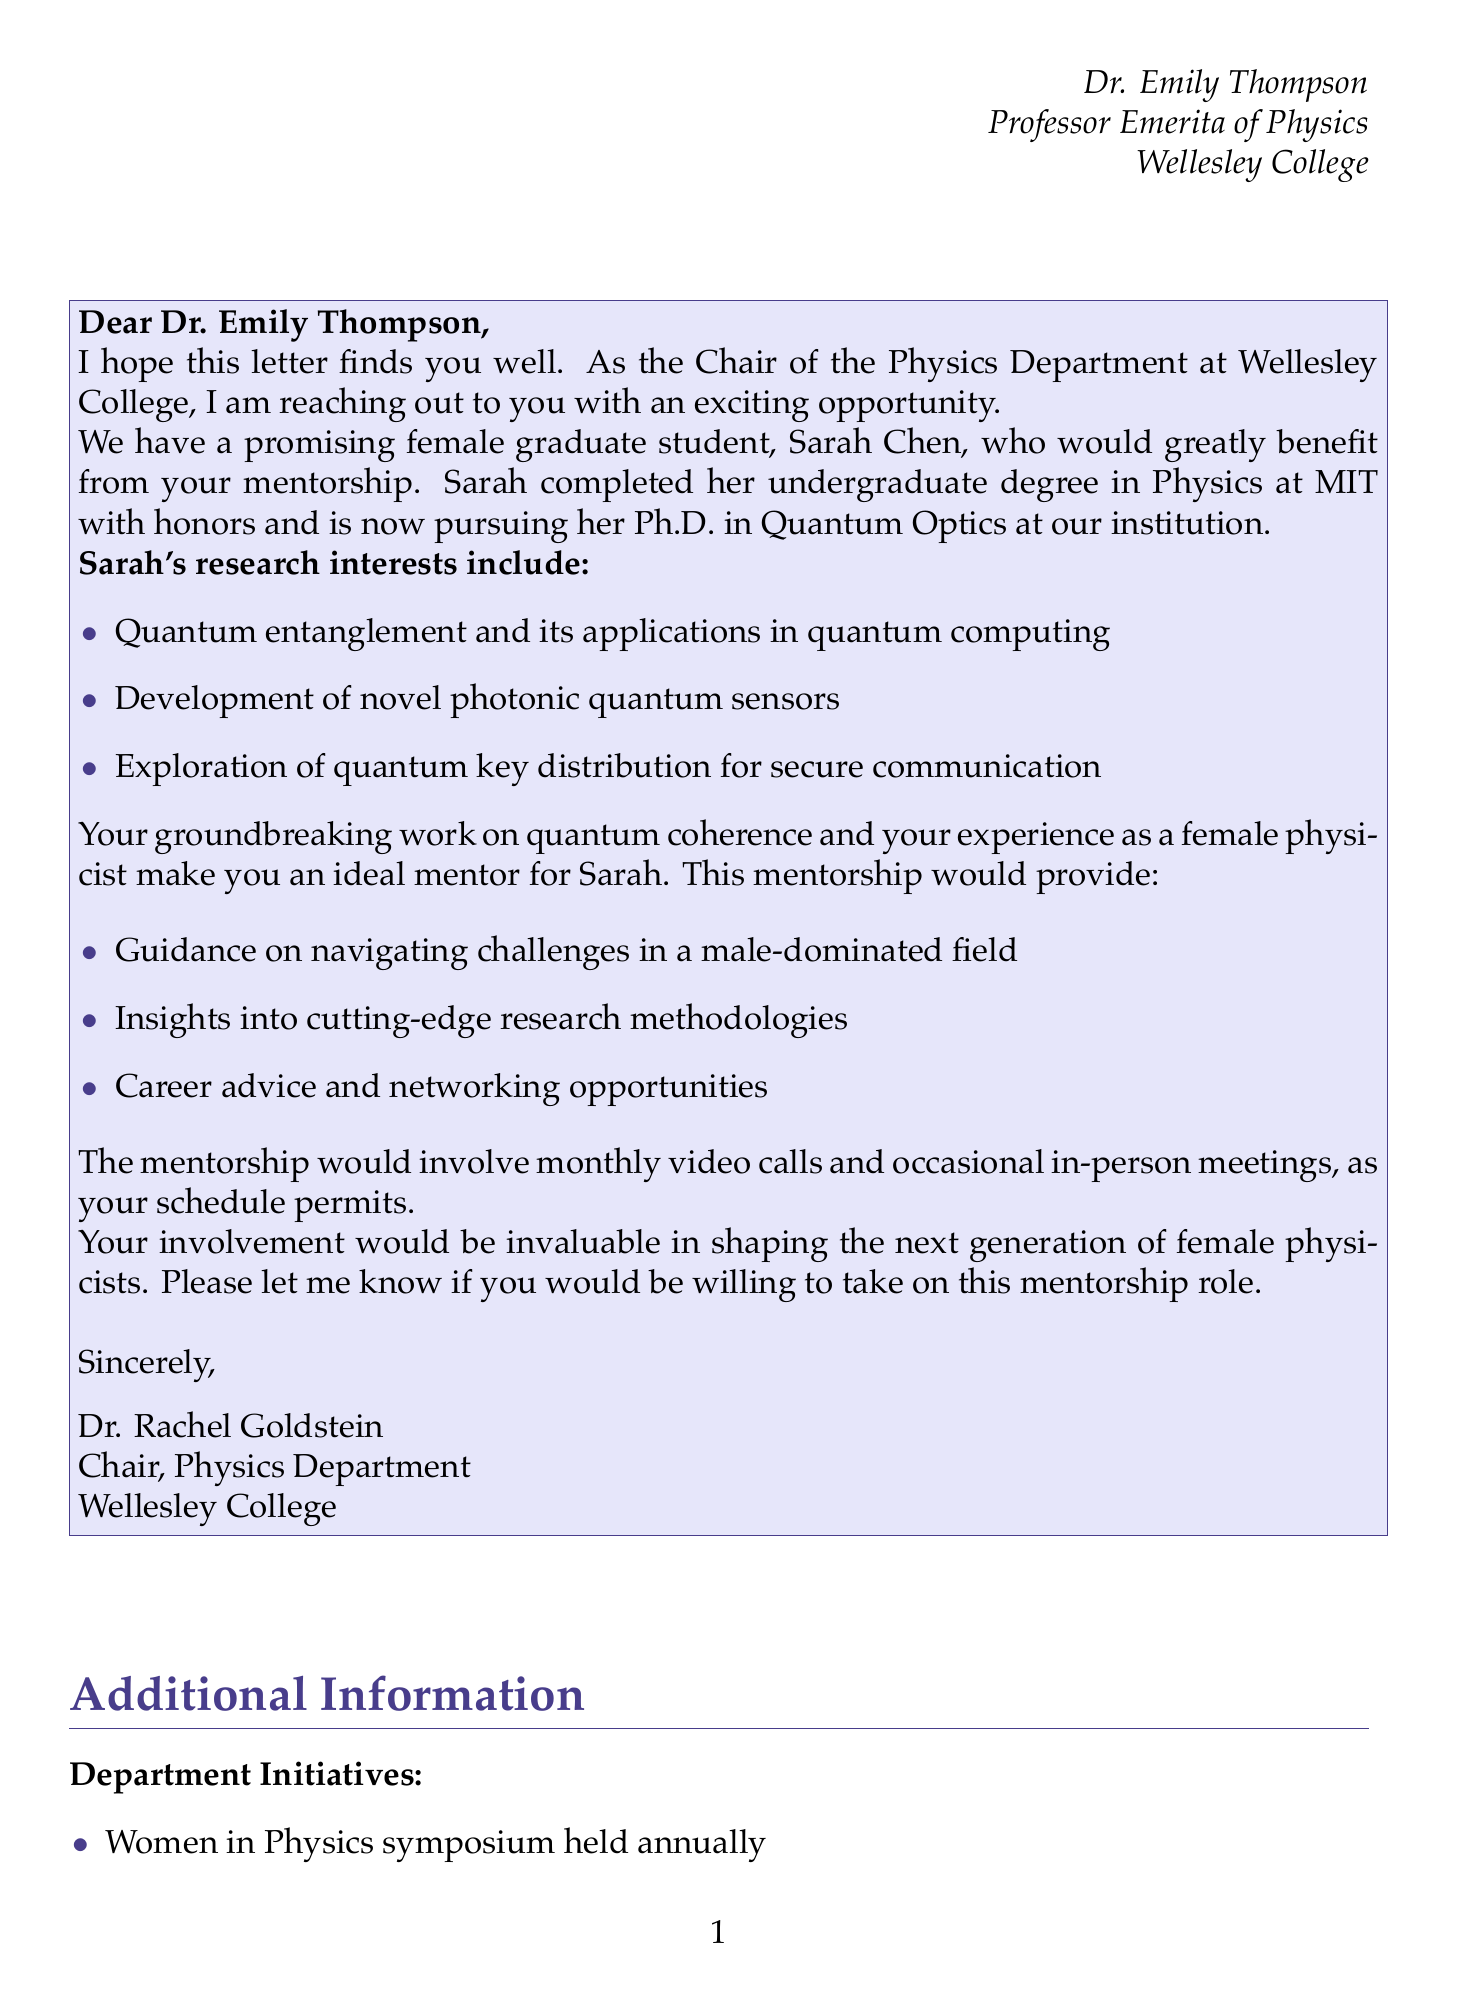What is the name of the graduate student? The document states the graduate student's name is Sarah Chen.
Answer: Sarah Chen What is Sarah's undergraduate alma mater? The document mentions that Sarah completed her undergraduate degree at MIT.
Answer: MIT What are Sarah's primary research interests? The letter lists three research interests of Sarah, which include quantum entanglement, photonic quantum sensors, and quantum key distribution.
Answer: Quantum entanglement and its applications in quantum computing, Development of novel photonic quantum sensors, Exploration of quantum key distribution for secure communication What is one achievement of Sarah Chen? The document provides Sarah's achievement of first place in a student paper competition, indicating her recognition in the field.
Answer: First place in the American Physical Society's Division of Laser Science student paper competition What is Dr. Emily Thompson's relation to the mentorship? The letter addresses Dr. Thompson as a potential mentor for the graduate student, implying her role in the mentorship.
Answer: Potential mentor How often would the mentorship involve video calls? The letter specifies that the mentorship would involve monthly video calls.
Answer: Monthly What is one benefit of mentoring mentioned in the letter? One benefit outlined is providing guidance on navigating challenges in a male-dominated field.
Answer: Guidance on navigating challenges in a male-dominated field Who signed the letter? The document concludes with a signature from Dr. Rachel Goldstein, indicating she is the sender.
Answer: Dr. Rachel Goldstein What department does Dr. Rachel Goldstein chair? The document clearly states that Dr. Goldstein is the Chair of the Physics Department at Wellesley College.
Answer: Physics Department 